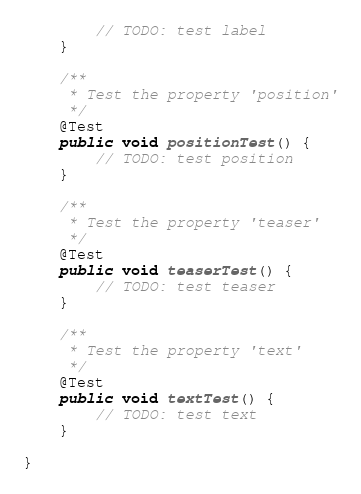Convert code to text. <code><loc_0><loc_0><loc_500><loc_500><_Java_>        // TODO: test label
    }

    /**
     * Test the property 'position'
     */
    @Test
    public void positionTest() {
        // TODO: test position
    }

    /**
     * Test the property 'teaser'
     */
    @Test
    public void teaserTest() {
        // TODO: test teaser
    }

    /**
     * Test the property 'text'
     */
    @Test
    public void textTest() {
        // TODO: test text
    }

}
</code> 